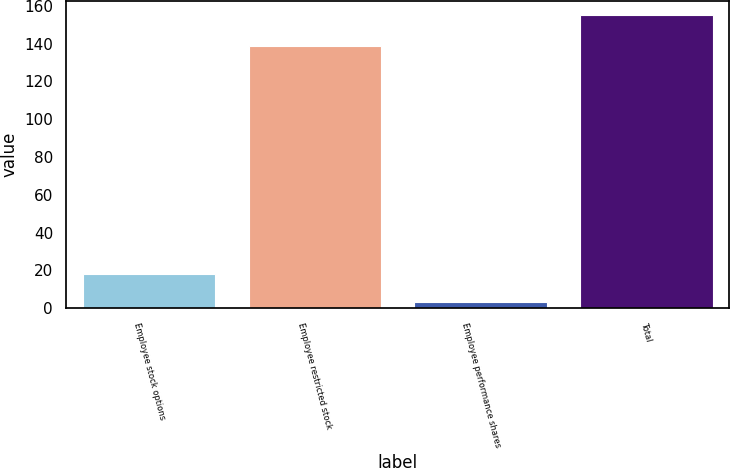Convert chart to OTSL. <chart><loc_0><loc_0><loc_500><loc_500><bar_chart><fcel>Employee stock options<fcel>Employee restricted stock<fcel>Employee performance shares<fcel>Total<nl><fcel>18.2<fcel>139<fcel>3<fcel>155<nl></chart> 